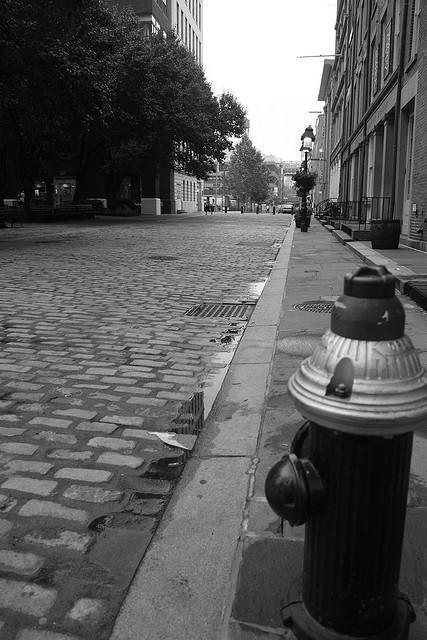How many people are wearing a jacket in the picture?
Give a very brief answer. 0. 